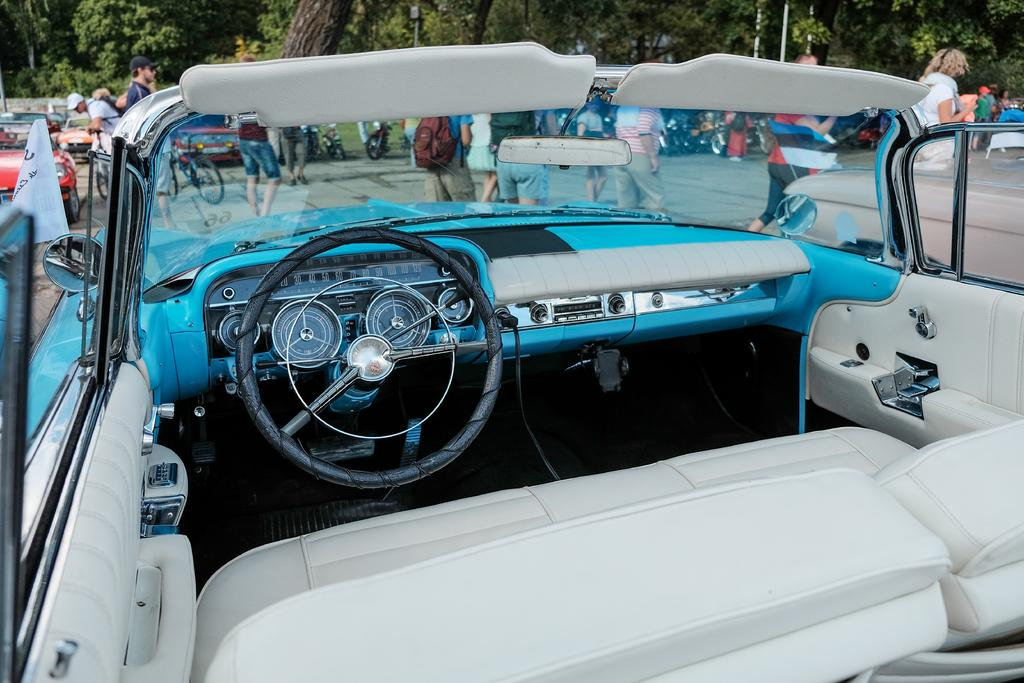What type of object is the main subject in the image? The image contains a vehicle. What features can be seen inside the vehicle? The vehicle has a steering wheel and a windshield. How many doors does the vehicle have? The vehicle has doors. What can be seen in the background of the image? There are trees, people, poles, and other vehicles in the background of the image. How many wristwatches can be seen on the people in the image? There is no mention of wristwatches in the image, so it cannot be determined how many are present. Are there any horses visible in the image? No, there are no horses present in the image. 